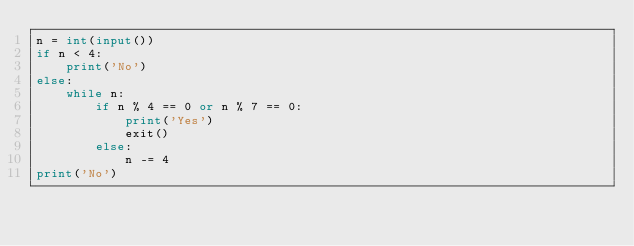<code> <loc_0><loc_0><loc_500><loc_500><_Python_>n = int(input())
if n < 4:
    print('No')
else:
    while n:
        if n % 4 == 0 or n % 7 == 0:
            print('Yes')
            exit()
        else:
            n -= 4
print('No')</code> 